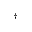Convert formula to latex. <formula><loc_0><loc_0><loc_500><loc_500>^ { \dagger }</formula> 